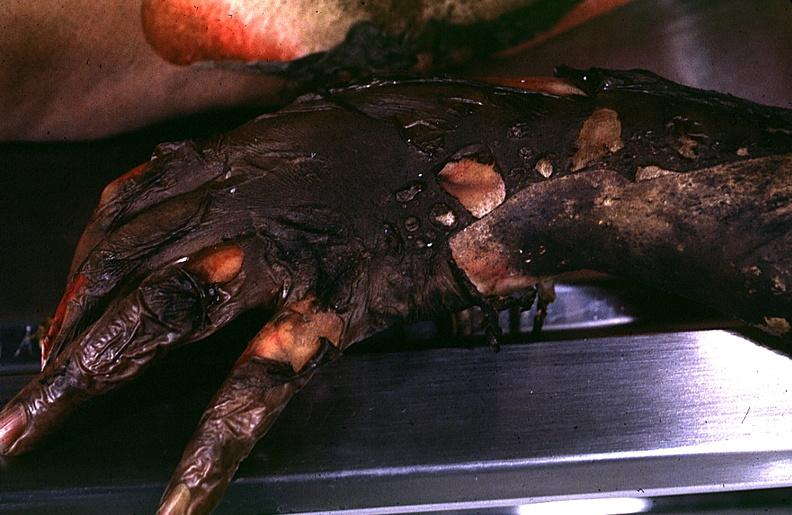do metastatic lung carcinoma burn?
Answer the question using a single word or phrase. No 